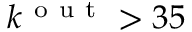Convert formula to latex. <formula><loc_0><loc_0><loc_500><loc_500>k ^ { o u t } > 3 5</formula> 